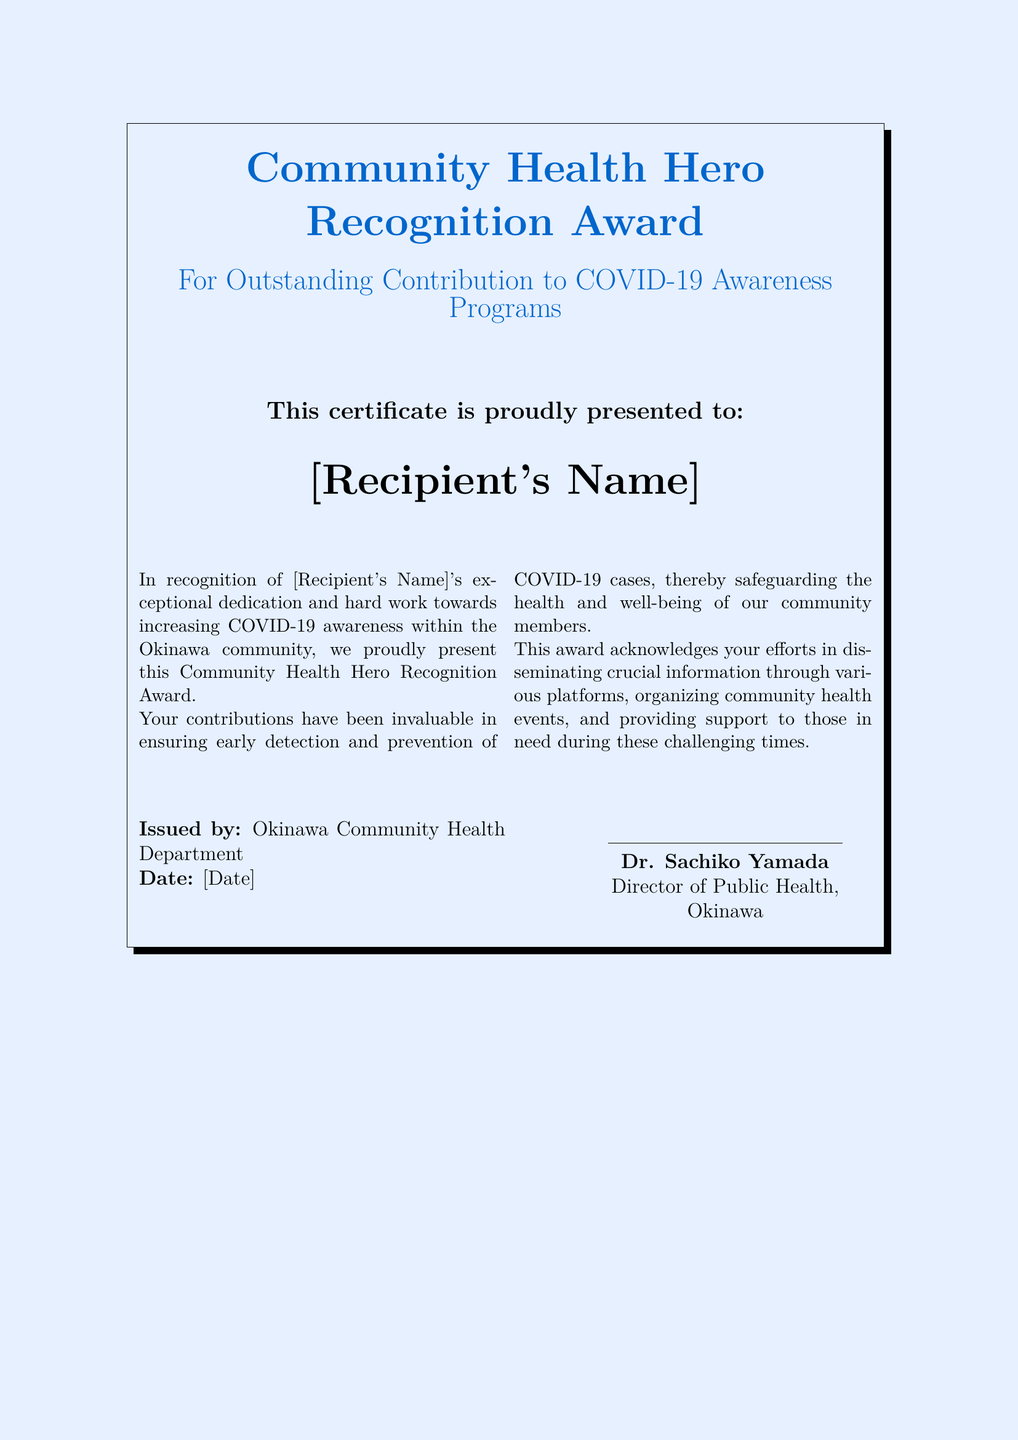What is the title of the award? The title of the award is presented in the document's header section and indicates its purpose.
Answer: Community Health Hero Recognition Award Who is the award presented to? The name of the recipient is directly stated in the document, signifying whom the award recognizes.
Answer: [Recipient's Name] What organization issued the certificate? The issuing organization is mentioned at the bottom of the document, indicating who is recognizing the recipient's contributions.
Answer: Okinawa Community Health Department What is the date on the certificate? The date is specified in the document, marking when the award was issued.
Answer: [Date] Who signed the certificate? The signature on the certificate reveals the authority behind the recognition, presented at the end of the document.
Answer: Dr. Sachiko Yamada What is the main purpose of the award? The purpose of the award can be understood from the thematic elements of the document, especially in the description provided.
Answer: Outstanding Contribution to COVID-19 Awareness Programs What is mentioned as one of the recipient's contributions? The document highlights the types of contributions made by the recipient, reflecting their efforts in the community.
Answer: Disseminating crucial information What role does Dr. Sachiko Yamada hold? The document describes the signer’s position to validate the authority of the award.
Answer: Director of Public Health 